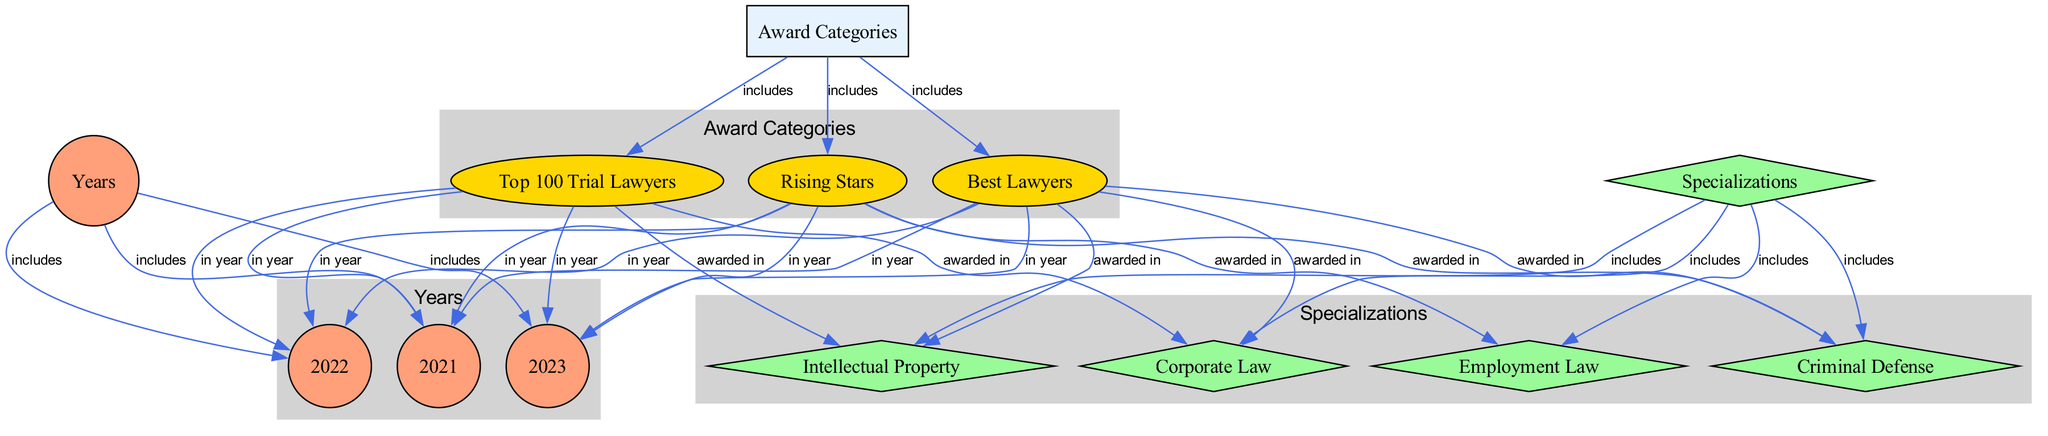What are the three award categories? The diagram identifies three specific award categories: Best Lawyers, Rising Stars, and Top 100 Trial Lawyers. These awards are visually grouped under "Award Categories," making it clear that they are related to attorney recognition.
Answer: Best Lawyers, Rising Stars, Top 100 Trial Lawyers Which specialization is awarded in Best Lawyers? The diagram connects Best Lawyers to multiple specializations: Corporate Law, Criminal Defense, and Intellectual Property. This indicates that attorneys in these three specializations can receive the Best Lawyers award.
Answer: Corporate Law, Criminal Defense, Intellectual Property How many specialization categories are present? The diagram shows four distinct specializations: Corporate Law, Criminal Defense, Intellectual Property, and Employment Law. Each of these is represented by a separate node under the "Specializations" category.
Answer: 4 In which year were all awards recognized? The edges leading from all three award categories point to the years 2021, 2022, and 2023 in equal measure. Therefore, it indicates that each award category (Best Lawyers, Rising Stars, and Top 100 Trial Lawyers) is recognized in all these years.
Answer: 2021, 2022, 2023 What are the specializations associated with Rising Stars? The diagram links Rising Stars to two specializations: Criminal Defense and Employment Law. This relationship shows that attorneys working in these fields receive the Rising Stars award.
Answer: Criminal Defense, Employment Law Which specialization has the most award categories associated with it? Analyzing the connections, we see that the specialization Criminal Defense connects to two award categories (Best Lawyers, Rising Stars) and has potential award connections because it is linked to both 2021 and 2022. Consequently, it could suggest higher recognition compared to others in terms of awards.
Answer: Criminal Defense How many edges link years to award categories? Each award category has edges leading to three years (2021, 2022, and 2023). As there are three award categories, this results in a total of nine edges linking the years to these awards.
Answer: 9 Which year is not linked to any award category? The diagram shows that all three years (2021, 2022, and 2023) are connected to the award categories. Thus, each year is represented with applicable connections, leaving no year unlinked.
Answer: None 